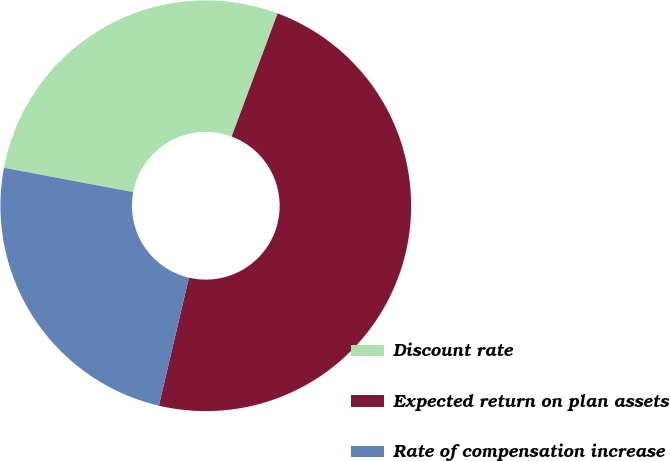<chart> <loc_0><loc_0><loc_500><loc_500><pie_chart><fcel>Discount rate<fcel>Expected return on plan assets<fcel>Rate of compensation increase<nl><fcel>27.73%<fcel>47.98%<fcel>24.29%<nl></chart> 